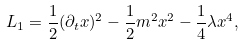Convert formula to latex. <formula><loc_0><loc_0><loc_500><loc_500>L _ { 1 } = \frac { 1 } { 2 } ( \partial _ { t } x ) ^ { 2 } - \frac { 1 } { 2 } m ^ { 2 } x ^ { 2 } - \frac { 1 } { 4 } \lambda x ^ { 4 } ,</formula> 